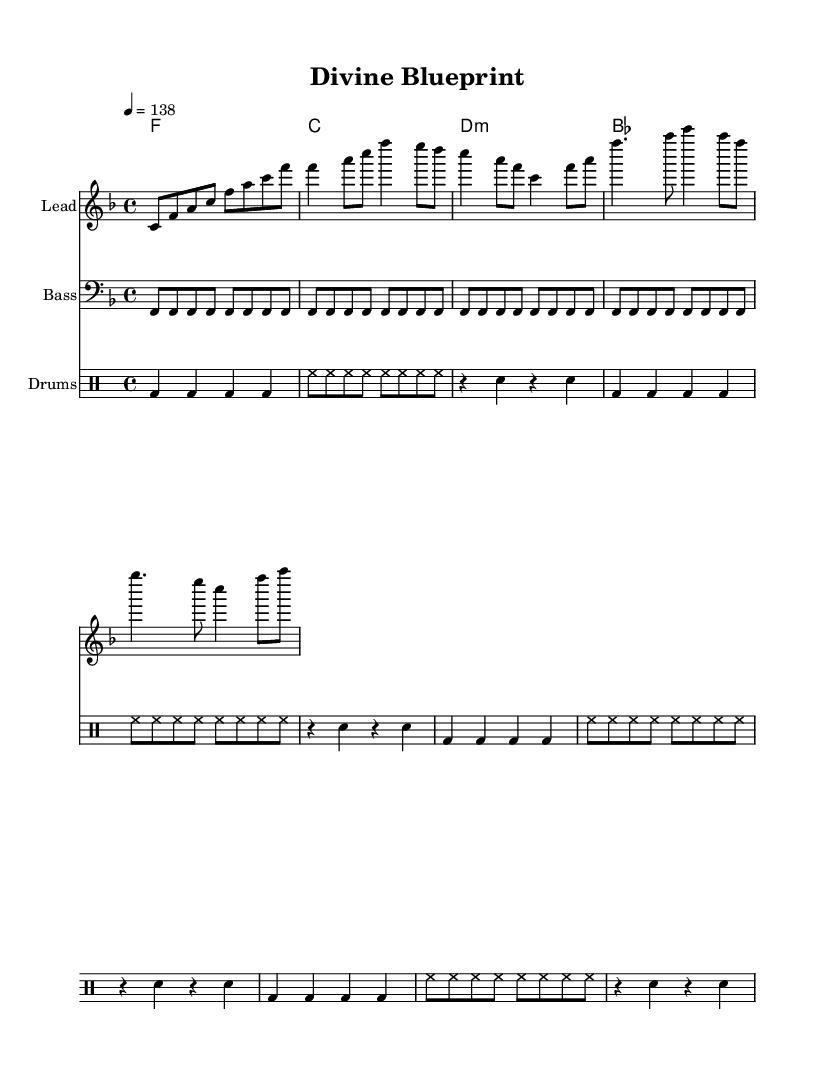What is the key signature of this music? The key signature is F major, which is indicated by one flat (B flat) and the absence of any sharps.
Answer: F major What is the time signature of this music? The time signature is 4/4, shown at the beginning of the score. This indicates that there are four beats in each measure and the quarter note receives one beat.
Answer: 4/4 What is the tempo marking for this piece? The tempo marking is 138 beats per minute, which is indicated as "4 = 138" after the time signature. This tells us how fast the piece should be played.
Answer: 138 How many measures are in the melody? The melody section consists of 8 measures, counting all the distinct musical phrases separately in the provided section.
Answer: 8 What is the name of the piece? The name of the piece is "Divine Blueprint," as indicated in the header section at the top of the score.
Answer: Divine Blueprint What type of musical texture is used in this piece? The piece employs a homophonic texture, where the melody is supported by harmonic progressions in the chords, a common feature in uplifting trance music.
Answer: Homophonic What is the main theme of the lyrics? The lyrics reference divine creation and intelligent design, further emphasizing the themes of purpose and existence as depicted in the text of the song.
Answer: Divine creation 